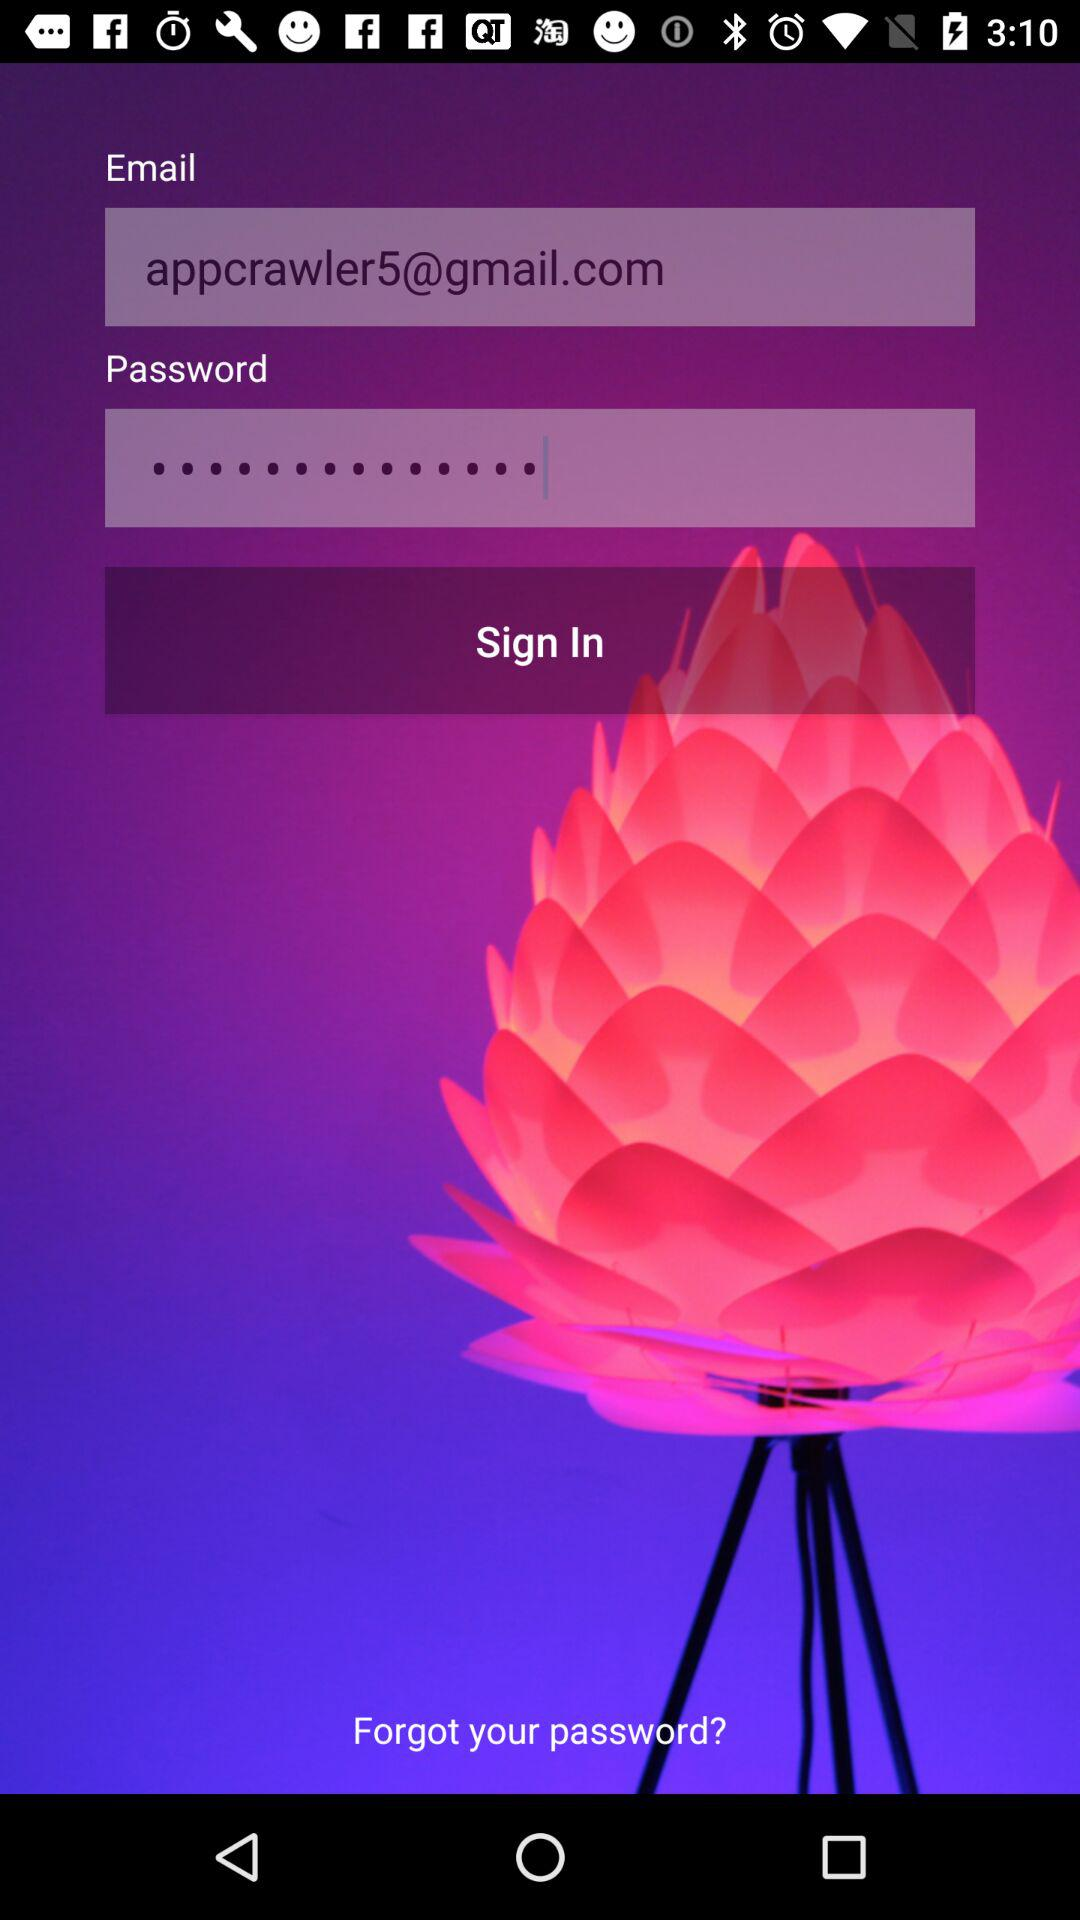Can we reset password?
When the provided information is insufficient, respond with <no answer>. <no answer> 